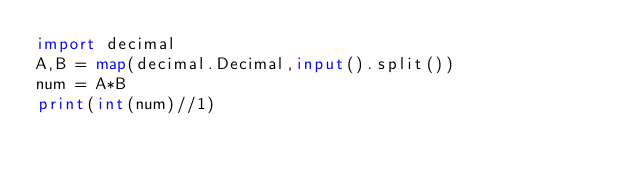Convert code to text. <code><loc_0><loc_0><loc_500><loc_500><_Python_>import decimal
A,B = map(decimal.Decimal,input().split())
num = A*B
print(int(num)//1)</code> 